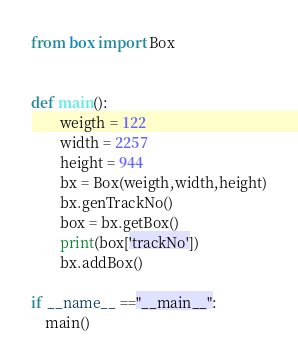Convert code to text. <code><loc_0><loc_0><loc_500><loc_500><_Python_>from box import Box


def main():
        weigth = 122
        width = 2257
        height = 944
        bx = Box(weigth,width,height)
        bx.genTrackNo()
        box = bx.getBox()
        print(box['trackNo'])
        bx.addBox()

if __name__ =="__main__":
    main()</code> 